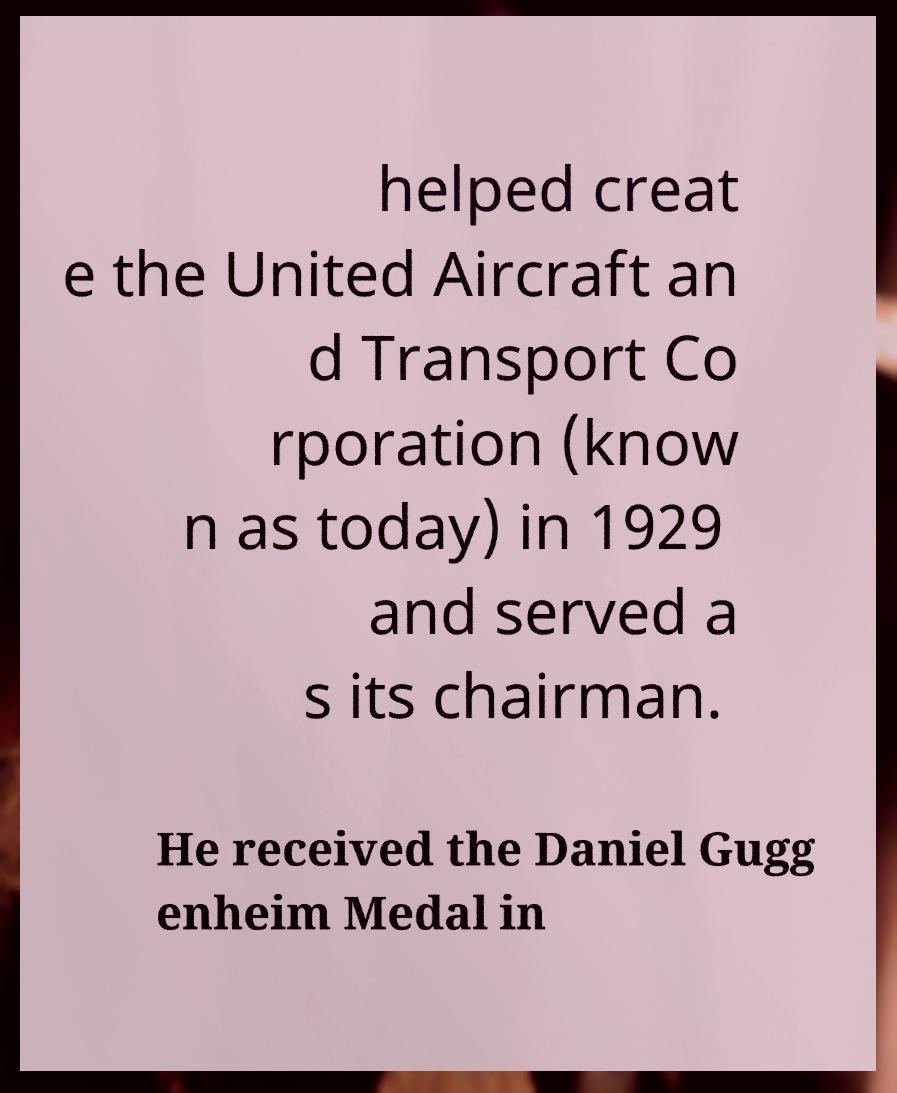I need the written content from this picture converted into text. Can you do that? helped creat e the United Aircraft an d Transport Co rporation (know n as today) in 1929 and served a s its chairman. He received the Daniel Gugg enheim Medal in 